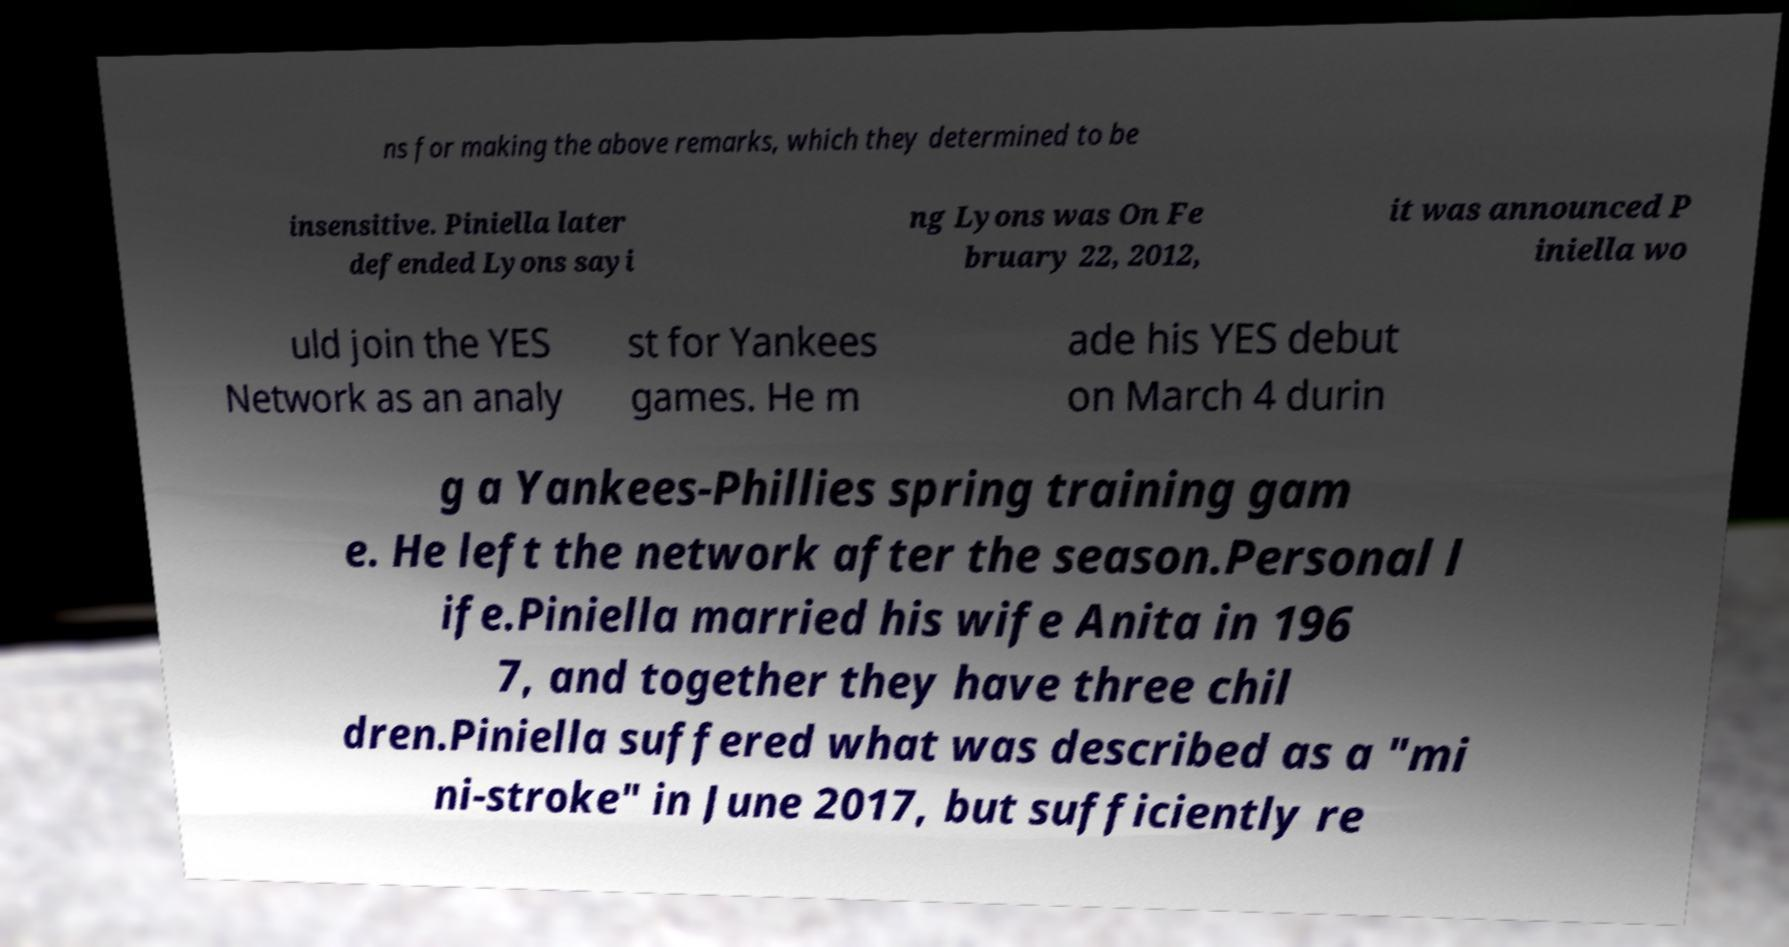Could you extract and type out the text from this image? ns for making the above remarks, which they determined to be insensitive. Piniella later defended Lyons sayi ng Lyons was On Fe bruary 22, 2012, it was announced P iniella wo uld join the YES Network as an analy st for Yankees games. He m ade his YES debut on March 4 durin g a Yankees-Phillies spring training gam e. He left the network after the season.Personal l ife.Piniella married his wife Anita in 196 7, and together they have three chil dren.Piniella suffered what was described as a "mi ni-stroke" in June 2017, but sufficiently re 